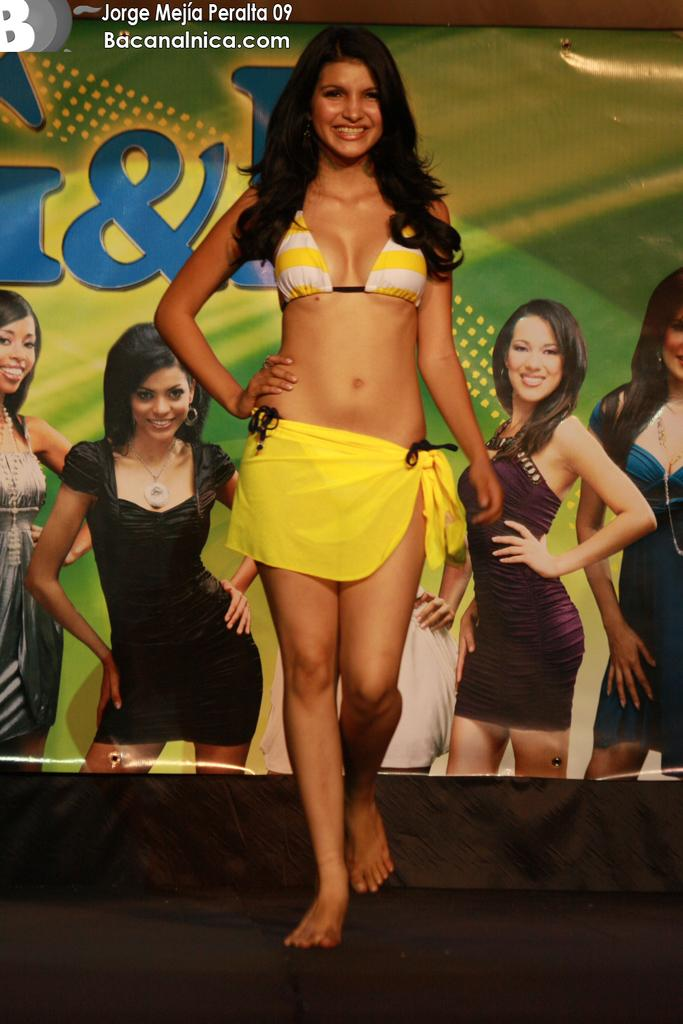What is happening in the image? There is a person in the image who is walking on the floor and smiling. What can be seen in the background of the image? There is a banner in the background of the image. Is there any text visible in the image? Yes, there is some text at the top of the image. What type of spade is the person using in the image? There is no spade present in the image; the person is walking and smiling. What medical advice is the doctor giving in the image? There is no doctor or medical advice present in the image; it features a person walking and smiling. 